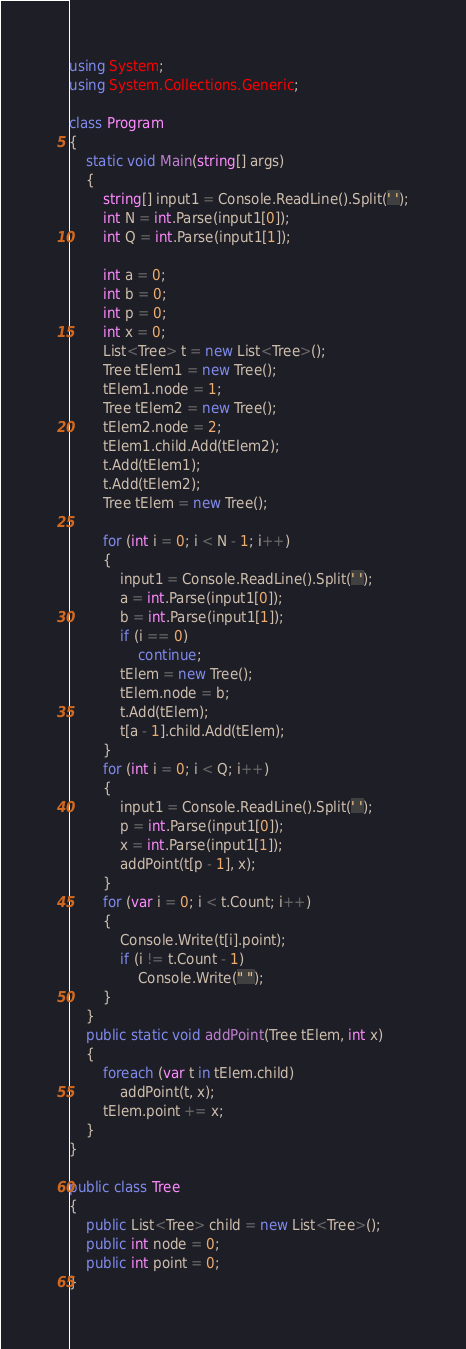<code> <loc_0><loc_0><loc_500><loc_500><_C#_>using System;
using System.Collections.Generic;

class Program
{
    static void Main(string[] args)
    {
        string[] input1 = Console.ReadLine().Split(' ');
        int N = int.Parse(input1[0]);
        int Q = int.Parse(input1[1]);

        int a = 0;
        int b = 0;
        int p = 0;
        int x = 0;
        List<Tree> t = new List<Tree>();
        Tree tElem1 = new Tree();
        tElem1.node = 1;
        Tree tElem2 = new Tree();
        tElem2.node = 2;
        tElem1.child.Add(tElem2);
        t.Add(tElem1);
        t.Add(tElem2);
        Tree tElem = new Tree();

        for (int i = 0; i < N - 1; i++)
        {
            input1 = Console.ReadLine().Split(' ');
            a = int.Parse(input1[0]);
            b = int.Parse(input1[1]);
            if (i == 0)
                continue;
            tElem = new Tree();
            tElem.node = b;
            t.Add(tElem);
            t[a - 1].child.Add(tElem);
        }
        for (int i = 0; i < Q; i++)
        {
            input1 = Console.ReadLine().Split(' ');
            p = int.Parse(input1[0]);
            x = int.Parse(input1[1]);
            addPoint(t[p - 1], x);
        }
        for (var i = 0; i < t.Count; i++)
        {
            Console.Write(t[i].point);
            if (i != t.Count - 1)
                Console.Write(" ");
        }
    }
    public static void addPoint(Tree tElem, int x)
    {
        foreach (var t in tElem.child)
            addPoint(t, x);
        tElem.point += x;
    }
}

public class Tree
{
    public List<Tree> child = new List<Tree>();
    public int node = 0;
    public int point = 0;
}</code> 